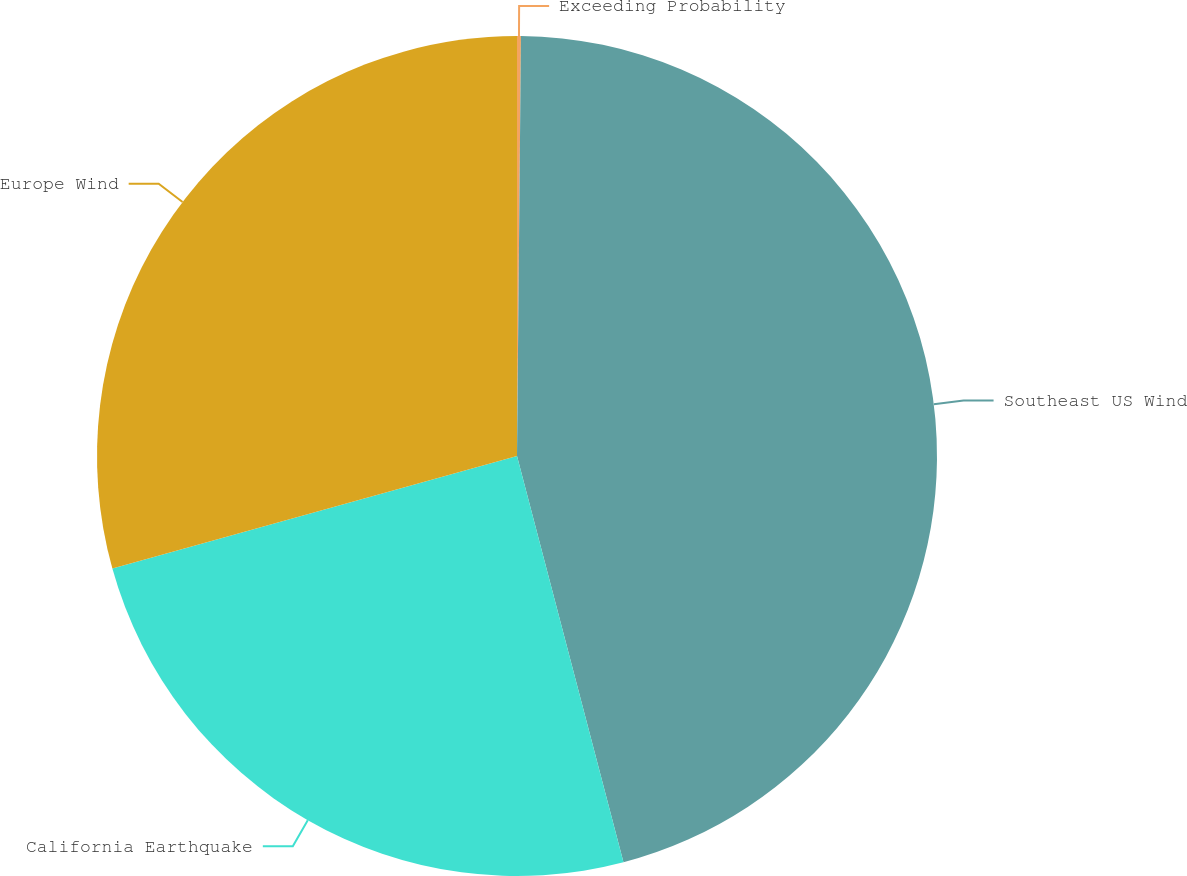<chart> <loc_0><loc_0><loc_500><loc_500><pie_chart><fcel>Exceeding Probability<fcel>Southeast US Wind<fcel>California Earthquake<fcel>Europe Wind<nl><fcel>0.15%<fcel>45.77%<fcel>24.76%<fcel>29.32%<nl></chart> 